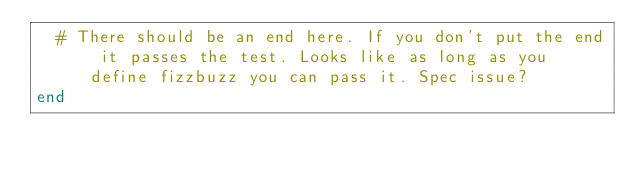<code> <loc_0><loc_0><loc_500><loc_500><_Ruby_>  # There should be an end here. If you don't put the end it passes the test. Looks like as long as you define fizzbuzz you can pass it. Spec issue?
end
</code> 